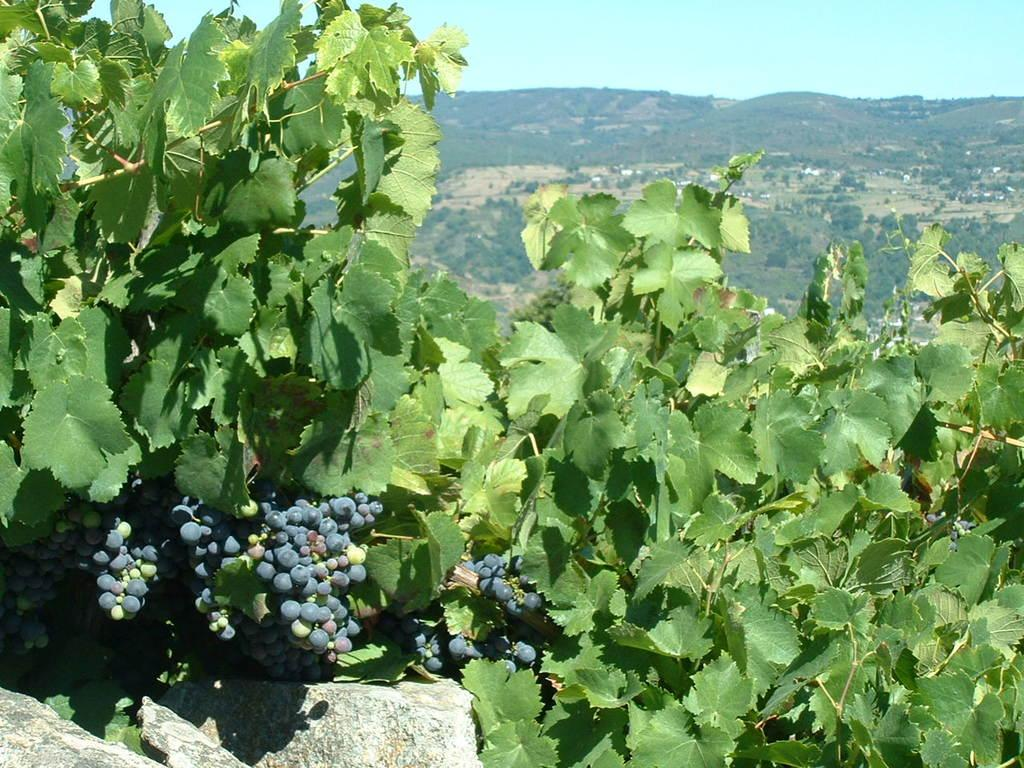What type of vegetation is present in the image? There are green color leaves in the image. What else can be seen in the image besides the leaves? There are berries visible in the image. What can be seen in the background of the image? There are trees and the sky visible in the background of the image. Where is the faucet located in the image? There is no faucet present in the image. Can you describe the flock of birds in the image? There are no birds or flocks present in the image. 